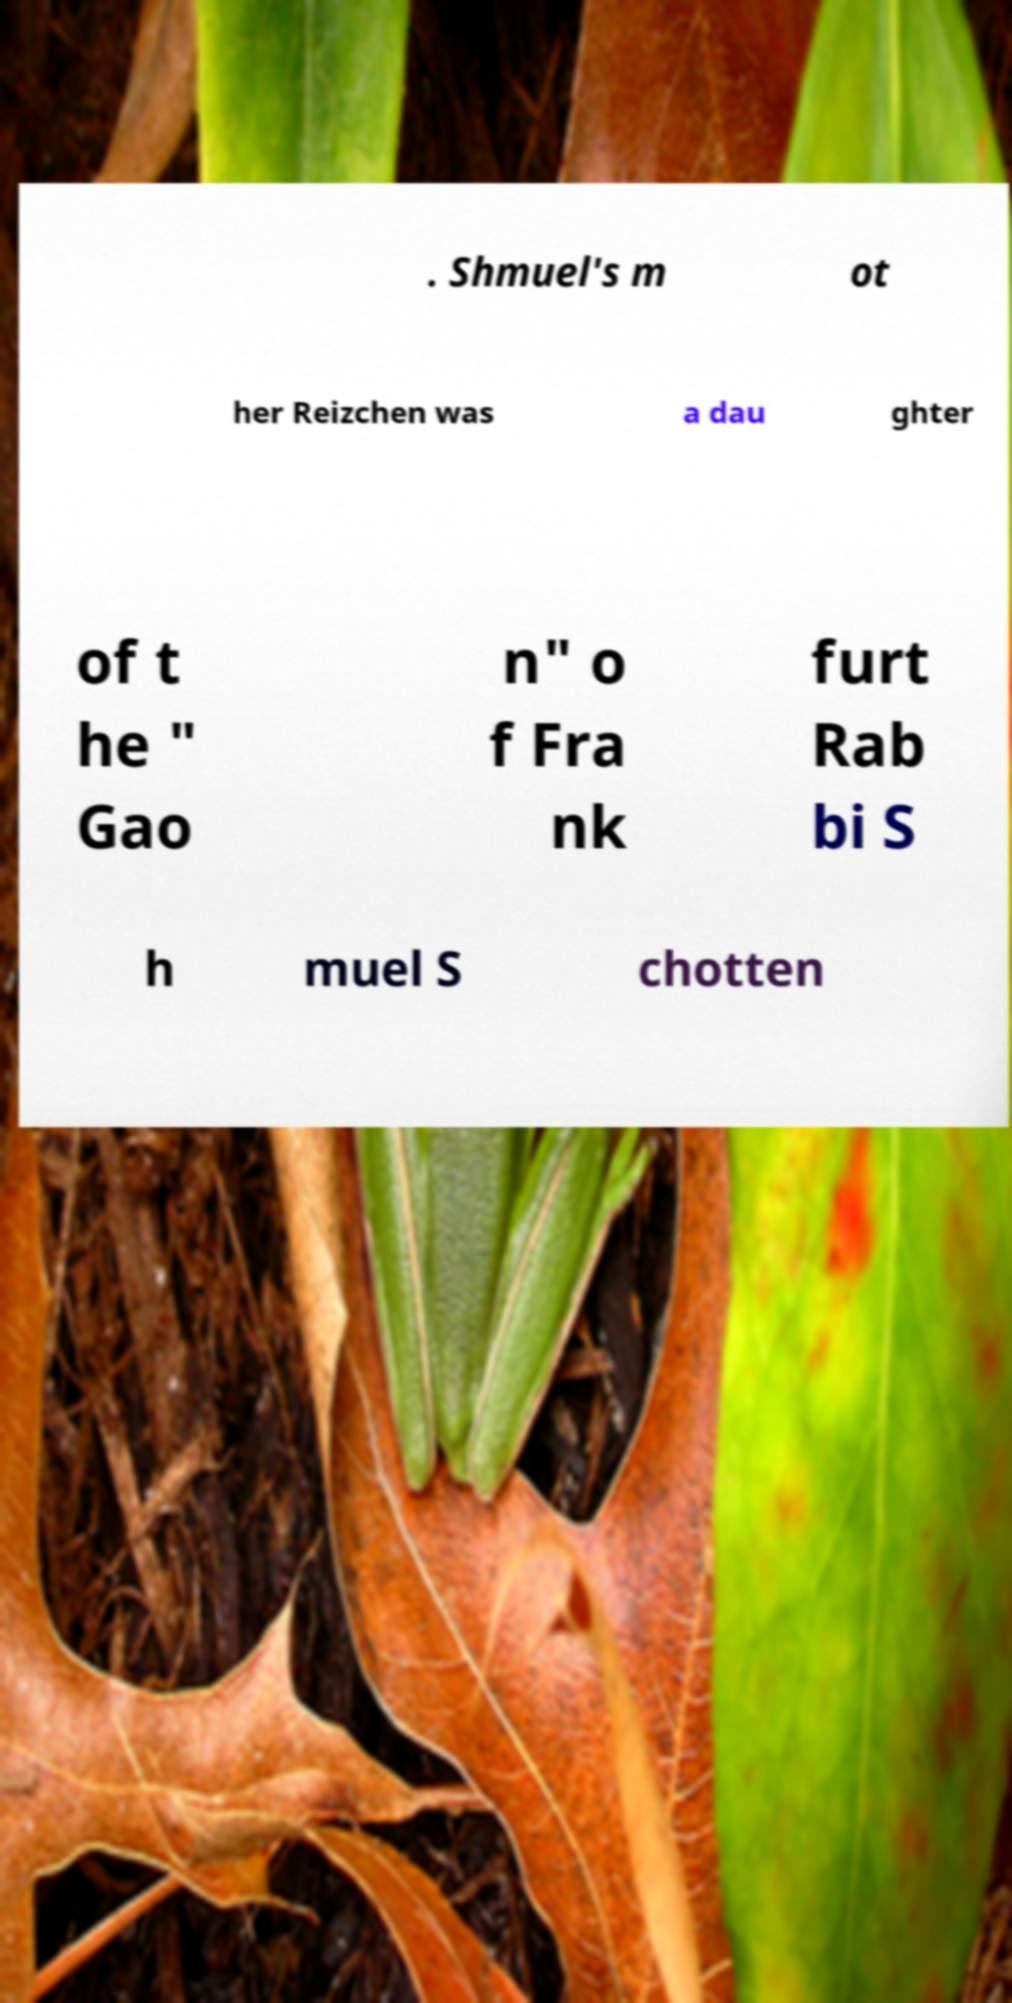Please read and relay the text visible in this image. What does it say? . Shmuel's m ot her Reizchen was a dau ghter of t he " Gao n" o f Fra nk furt Rab bi S h muel S chotten 